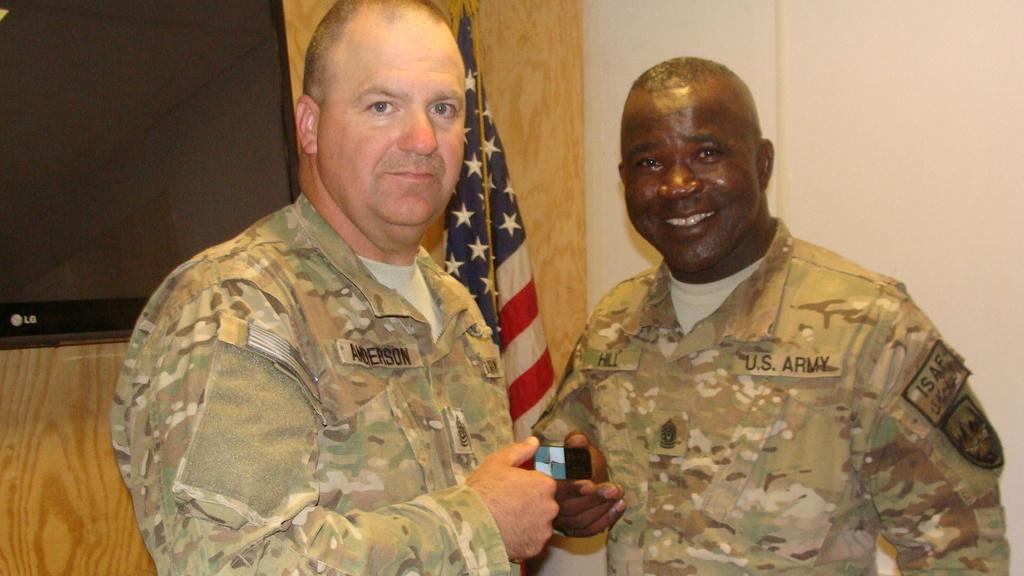Could you give a brief overview of what you see in this image? In this picture we can see two men standing here, in the background there is a wall, on the left there is a television, behind it we can see a flag. 